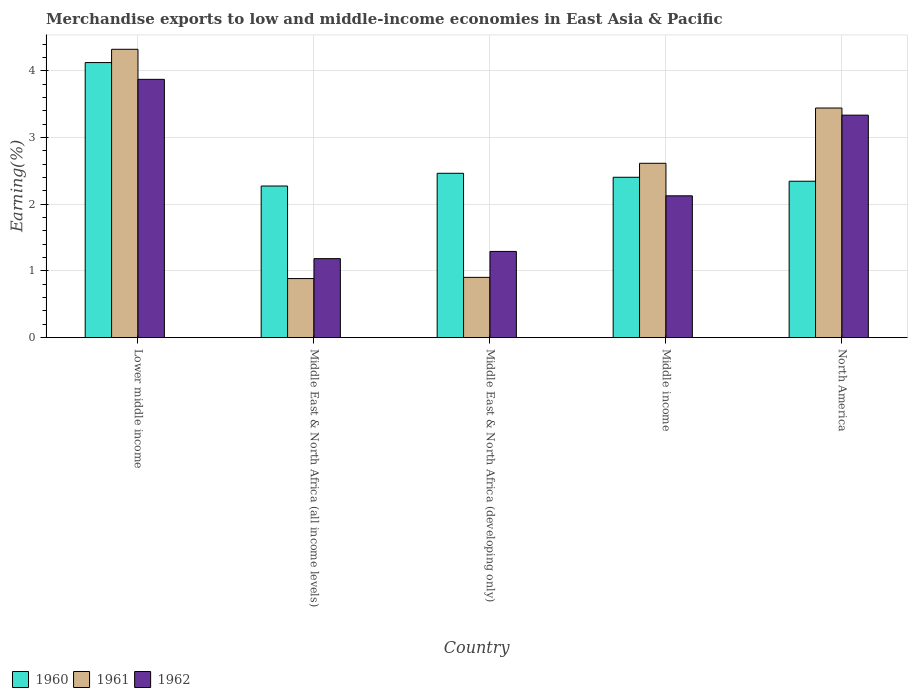How many bars are there on the 3rd tick from the left?
Make the answer very short. 3. How many bars are there on the 2nd tick from the right?
Offer a very short reply. 3. What is the label of the 3rd group of bars from the left?
Keep it short and to the point. Middle East & North Africa (developing only). In how many cases, is the number of bars for a given country not equal to the number of legend labels?
Ensure brevity in your answer.  0. What is the percentage of amount earned from merchandise exports in 1961 in North America?
Give a very brief answer. 3.44. Across all countries, what is the maximum percentage of amount earned from merchandise exports in 1962?
Ensure brevity in your answer.  3.87. Across all countries, what is the minimum percentage of amount earned from merchandise exports in 1962?
Give a very brief answer. 1.19. In which country was the percentage of amount earned from merchandise exports in 1962 maximum?
Offer a terse response. Lower middle income. In which country was the percentage of amount earned from merchandise exports in 1960 minimum?
Offer a very short reply. Middle East & North Africa (all income levels). What is the total percentage of amount earned from merchandise exports in 1962 in the graph?
Your answer should be very brief. 11.81. What is the difference between the percentage of amount earned from merchandise exports in 1962 in Middle East & North Africa (all income levels) and that in Middle income?
Your response must be concise. -0.94. What is the difference between the percentage of amount earned from merchandise exports in 1960 in Middle income and the percentage of amount earned from merchandise exports in 1961 in Lower middle income?
Provide a short and direct response. -1.92. What is the average percentage of amount earned from merchandise exports in 1961 per country?
Your response must be concise. 2.43. What is the difference between the percentage of amount earned from merchandise exports of/in 1960 and percentage of amount earned from merchandise exports of/in 1962 in Middle East & North Africa (all income levels)?
Provide a succinct answer. 1.09. In how many countries, is the percentage of amount earned from merchandise exports in 1961 greater than 1 %?
Ensure brevity in your answer.  3. What is the ratio of the percentage of amount earned from merchandise exports in 1960 in Lower middle income to that in North America?
Provide a short and direct response. 1.76. What is the difference between the highest and the second highest percentage of amount earned from merchandise exports in 1960?
Provide a short and direct response. 0.06. What is the difference between the highest and the lowest percentage of amount earned from merchandise exports in 1962?
Provide a succinct answer. 2.69. In how many countries, is the percentage of amount earned from merchandise exports in 1960 greater than the average percentage of amount earned from merchandise exports in 1960 taken over all countries?
Keep it short and to the point. 1. What does the 1st bar from the right in Lower middle income represents?
Offer a very short reply. 1962. Is it the case that in every country, the sum of the percentage of amount earned from merchandise exports in 1961 and percentage of amount earned from merchandise exports in 1962 is greater than the percentage of amount earned from merchandise exports in 1960?
Give a very brief answer. No. How many bars are there?
Offer a very short reply. 15. Does the graph contain any zero values?
Give a very brief answer. No. Where does the legend appear in the graph?
Offer a terse response. Bottom left. How many legend labels are there?
Your response must be concise. 3. How are the legend labels stacked?
Your answer should be very brief. Horizontal. What is the title of the graph?
Make the answer very short. Merchandise exports to low and middle-income economies in East Asia & Pacific. What is the label or title of the X-axis?
Make the answer very short. Country. What is the label or title of the Y-axis?
Make the answer very short. Earning(%). What is the Earning(%) in 1960 in Lower middle income?
Keep it short and to the point. 4.12. What is the Earning(%) of 1961 in Lower middle income?
Provide a short and direct response. 4.32. What is the Earning(%) of 1962 in Lower middle income?
Your answer should be very brief. 3.87. What is the Earning(%) in 1960 in Middle East & North Africa (all income levels)?
Provide a short and direct response. 2.27. What is the Earning(%) in 1961 in Middle East & North Africa (all income levels)?
Your answer should be compact. 0.89. What is the Earning(%) in 1962 in Middle East & North Africa (all income levels)?
Your response must be concise. 1.19. What is the Earning(%) in 1960 in Middle East & North Africa (developing only)?
Offer a terse response. 2.46. What is the Earning(%) in 1961 in Middle East & North Africa (developing only)?
Give a very brief answer. 0.9. What is the Earning(%) of 1962 in Middle East & North Africa (developing only)?
Offer a terse response. 1.29. What is the Earning(%) of 1960 in Middle income?
Offer a very short reply. 2.4. What is the Earning(%) of 1961 in Middle income?
Your response must be concise. 2.61. What is the Earning(%) of 1962 in Middle income?
Keep it short and to the point. 2.13. What is the Earning(%) in 1960 in North America?
Make the answer very short. 2.35. What is the Earning(%) of 1961 in North America?
Ensure brevity in your answer.  3.44. What is the Earning(%) of 1962 in North America?
Give a very brief answer. 3.34. Across all countries, what is the maximum Earning(%) of 1960?
Your response must be concise. 4.12. Across all countries, what is the maximum Earning(%) of 1961?
Make the answer very short. 4.32. Across all countries, what is the maximum Earning(%) of 1962?
Ensure brevity in your answer.  3.87. Across all countries, what is the minimum Earning(%) in 1960?
Your response must be concise. 2.27. Across all countries, what is the minimum Earning(%) in 1961?
Your answer should be compact. 0.89. Across all countries, what is the minimum Earning(%) of 1962?
Offer a very short reply. 1.19. What is the total Earning(%) of 1960 in the graph?
Your response must be concise. 13.61. What is the total Earning(%) in 1961 in the graph?
Provide a succinct answer. 12.17. What is the total Earning(%) of 1962 in the graph?
Keep it short and to the point. 11.81. What is the difference between the Earning(%) in 1960 in Lower middle income and that in Middle East & North Africa (all income levels)?
Your response must be concise. 1.85. What is the difference between the Earning(%) of 1961 in Lower middle income and that in Middle East & North Africa (all income levels)?
Your answer should be compact. 3.44. What is the difference between the Earning(%) of 1962 in Lower middle income and that in Middle East & North Africa (all income levels)?
Make the answer very short. 2.69. What is the difference between the Earning(%) in 1960 in Lower middle income and that in Middle East & North Africa (developing only)?
Offer a terse response. 1.66. What is the difference between the Earning(%) in 1961 in Lower middle income and that in Middle East & North Africa (developing only)?
Give a very brief answer. 3.42. What is the difference between the Earning(%) in 1962 in Lower middle income and that in Middle East & North Africa (developing only)?
Give a very brief answer. 2.58. What is the difference between the Earning(%) of 1960 in Lower middle income and that in Middle income?
Offer a very short reply. 1.72. What is the difference between the Earning(%) in 1961 in Lower middle income and that in Middle income?
Offer a terse response. 1.71. What is the difference between the Earning(%) of 1962 in Lower middle income and that in Middle income?
Your answer should be very brief. 1.75. What is the difference between the Earning(%) of 1960 in Lower middle income and that in North America?
Keep it short and to the point. 1.78. What is the difference between the Earning(%) in 1961 in Lower middle income and that in North America?
Provide a succinct answer. 0.88. What is the difference between the Earning(%) of 1962 in Lower middle income and that in North America?
Offer a very short reply. 0.54. What is the difference between the Earning(%) in 1960 in Middle East & North Africa (all income levels) and that in Middle East & North Africa (developing only)?
Offer a terse response. -0.19. What is the difference between the Earning(%) of 1961 in Middle East & North Africa (all income levels) and that in Middle East & North Africa (developing only)?
Ensure brevity in your answer.  -0.02. What is the difference between the Earning(%) of 1962 in Middle East & North Africa (all income levels) and that in Middle East & North Africa (developing only)?
Your answer should be compact. -0.11. What is the difference between the Earning(%) in 1960 in Middle East & North Africa (all income levels) and that in Middle income?
Provide a short and direct response. -0.13. What is the difference between the Earning(%) of 1961 in Middle East & North Africa (all income levels) and that in Middle income?
Ensure brevity in your answer.  -1.73. What is the difference between the Earning(%) in 1962 in Middle East & North Africa (all income levels) and that in Middle income?
Make the answer very short. -0.94. What is the difference between the Earning(%) in 1960 in Middle East & North Africa (all income levels) and that in North America?
Ensure brevity in your answer.  -0.07. What is the difference between the Earning(%) in 1961 in Middle East & North Africa (all income levels) and that in North America?
Ensure brevity in your answer.  -2.56. What is the difference between the Earning(%) in 1962 in Middle East & North Africa (all income levels) and that in North America?
Provide a short and direct response. -2.15. What is the difference between the Earning(%) in 1960 in Middle East & North Africa (developing only) and that in Middle income?
Provide a short and direct response. 0.06. What is the difference between the Earning(%) of 1961 in Middle East & North Africa (developing only) and that in Middle income?
Keep it short and to the point. -1.71. What is the difference between the Earning(%) of 1962 in Middle East & North Africa (developing only) and that in Middle income?
Provide a succinct answer. -0.83. What is the difference between the Earning(%) in 1960 in Middle East & North Africa (developing only) and that in North America?
Make the answer very short. 0.12. What is the difference between the Earning(%) of 1961 in Middle East & North Africa (developing only) and that in North America?
Your answer should be very brief. -2.54. What is the difference between the Earning(%) in 1962 in Middle East & North Africa (developing only) and that in North America?
Make the answer very short. -2.04. What is the difference between the Earning(%) of 1960 in Middle income and that in North America?
Your response must be concise. 0.06. What is the difference between the Earning(%) in 1961 in Middle income and that in North America?
Make the answer very short. -0.83. What is the difference between the Earning(%) of 1962 in Middle income and that in North America?
Give a very brief answer. -1.21. What is the difference between the Earning(%) of 1960 in Lower middle income and the Earning(%) of 1961 in Middle East & North Africa (all income levels)?
Provide a short and direct response. 3.24. What is the difference between the Earning(%) in 1960 in Lower middle income and the Earning(%) in 1962 in Middle East & North Africa (all income levels)?
Give a very brief answer. 2.94. What is the difference between the Earning(%) of 1961 in Lower middle income and the Earning(%) of 1962 in Middle East & North Africa (all income levels)?
Your answer should be very brief. 3.14. What is the difference between the Earning(%) of 1960 in Lower middle income and the Earning(%) of 1961 in Middle East & North Africa (developing only)?
Keep it short and to the point. 3.22. What is the difference between the Earning(%) of 1960 in Lower middle income and the Earning(%) of 1962 in Middle East & North Africa (developing only)?
Provide a short and direct response. 2.83. What is the difference between the Earning(%) in 1961 in Lower middle income and the Earning(%) in 1962 in Middle East & North Africa (developing only)?
Your response must be concise. 3.03. What is the difference between the Earning(%) in 1960 in Lower middle income and the Earning(%) in 1961 in Middle income?
Your answer should be compact. 1.51. What is the difference between the Earning(%) in 1960 in Lower middle income and the Earning(%) in 1962 in Middle income?
Ensure brevity in your answer.  2. What is the difference between the Earning(%) of 1961 in Lower middle income and the Earning(%) of 1962 in Middle income?
Ensure brevity in your answer.  2.2. What is the difference between the Earning(%) in 1960 in Lower middle income and the Earning(%) in 1961 in North America?
Keep it short and to the point. 0.68. What is the difference between the Earning(%) of 1960 in Lower middle income and the Earning(%) of 1962 in North America?
Keep it short and to the point. 0.79. What is the difference between the Earning(%) in 1961 in Lower middle income and the Earning(%) in 1962 in North America?
Make the answer very short. 0.99. What is the difference between the Earning(%) of 1960 in Middle East & North Africa (all income levels) and the Earning(%) of 1961 in Middle East & North Africa (developing only)?
Provide a succinct answer. 1.37. What is the difference between the Earning(%) in 1960 in Middle East & North Africa (all income levels) and the Earning(%) in 1962 in Middle East & North Africa (developing only)?
Provide a short and direct response. 0.98. What is the difference between the Earning(%) in 1961 in Middle East & North Africa (all income levels) and the Earning(%) in 1962 in Middle East & North Africa (developing only)?
Give a very brief answer. -0.41. What is the difference between the Earning(%) in 1960 in Middle East & North Africa (all income levels) and the Earning(%) in 1961 in Middle income?
Ensure brevity in your answer.  -0.34. What is the difference between the Earning(%) in 1960 in Middle East & North Africa (all income levels) and the Earning(%) in 1962 in Middle income?
Your response must be concise. 0.15. What is the difference between the Earning(%) in 1961 in Middle East & North Africa (all income levels) and the Earning(%) in 1962 in Middle income?
Give a very brief answer. -1.24. What is the difference between the Earning(%) of 1960 in Middle East & North Africa (all income levels) and the Earning(%) of 1961 in North America?
Provide a succinct answer. -1.17. What is the difference between the Earning(%) of 1960 in Middle East & North Africa (all income levels) and the Earning(%) of 1962 in North America?
Offer a very short reply. -1.06. What is the difference between the Earning(%) of 1961 in Middle East & North Africa (all income levels) and the Earning(%) of 1962 in North America?
Your answer should be very brief. -2.45. What is the difference between the Earning(%) in 1960 in Middle East & North Africa (developing only) and the Earning(%) in 1962 in Middle income?
Keep it short and to the point. 0.34. What is the difference between the Earning(%) in 1961 in Middle East & North Africa (developing only) and the Earning(%) in 1962 in Middle income?
Your answer should be compact. -1.22. What is the difference between the Earning(%) of 1960 in Middle East & North Africa (developing only) and the Earning(%) of 1961 in North America?
Provide a short and direct response. -0.98. What is the difference between the Earning(%) in 1960 in Middle East & North Africa (developing only) and the Earning(%) in 1962 in North America?
Give a very brief answer. -0.87. What is the difference between the Earning(%) of 1961 in Middle East & North Africa (developing only) and the Earning(%) of 1962 in North America?
Provide a succinct answer. -2.43. What is the difference between the Earning(%) of 1960 in Middle income and the Earning(%) of 1961 in North America?
Make the answer very short. -1.04. What is the difference between the Earning(%) of 1960 in Middle income and the Earning(%) of 1962 in North America?
Ensure brevity in your answer.  -0.93. What is the difference between the Earning(%) in 1961 in Middle income and the Earning(%) in 1962 in North America?
Your answer should be compact. -0.72. What is the average Earning(%) of 1960 per country?
Your answer should be compact. 2.72. What is the average Earning(%) of 1961 per country?
Provide a short and direct response. 2.43. What is the average Earning(%) in 1962 per country?
Make the answer very short. 2.36. What is the difference between the Earning(%) in 1960 and Earning(%) in 1961 in Lower middle income?
Give a very brief answer. -0.2. What is the difference between the Earning(%) in 1960 and Earning(%) in 1962 in Lower middle income?
Give a very brief answer. 0.25. What is the difference between the Earning(%) in 1961 and Earning(%) in 1962 in Lower middle income?
Your answer should be very brief. 0.45. What is the difference between the Earning(%) in 1960 and Earning(%) in 1961 in Middle East & North Africa (all income levels)?
Your answer should be very brief. 1.39. What is the difference between the Earning(%) in 1960 and Earning(%) in 1962 in Middle East & North Africa (all income levels)?
Keep it short and to the point. 1.09. What is the difference between the Earning(%) in 1961 and Earning(%) in 1962 in Middle East & North Africa (all income levels)?
Make the answer very short. -0.3. What is the difference between the Earning(%) in 1960 and Earning(%) in 1961 in Middle East & North Africa (developing only)?
Give a very brief answer. 1.56. What is the difference between the Earning(%) in 1960 and Earning(%) in 1962 in Middle East & North Africa (developing only)?
Your response must be concise. 1.17. What is the difference between the Earning(%) in 1961 and Earning(%) in 1962 in Middle East & North Africa (developing only)?
Give a very brief answer. -0.39. What is the difference between the Earning(%) of 1960 and Earning(%) of 1961 in Middle income?
Your answer should be compact. -0.21. What is the difference between the Earning(%) in 1960 and Earning(%) in 1962 in Middle income?
Make the answer very short. 0.28. What is the difference between the Earning(%) in 1961 and Earning(%) in 1962 in Middle income?
Your answer should be compact. 0.49. What is the difference between the Earning(%) of 1960 and Earning(%) of 1961 in North America?
Give a very brief answer. -1.1. What is the difference between the Earning(%) in 1960 and Earning(%) in 1962 in North America?
Offer a very short reply. -0.99. What is the difference between the Earning(%) in 1961 and Earning(%) in 1962 in North America?
Provide a short and direct response. 0.11. What is the ratio of the Earning(%) in 1960 in Lower middle income to that in Middle East & North Africa (all income levels)?
Offer a terse response. 1.81. What is the ratio of the Earning(%) of 1961 in Lower middle income to that in Middle East & North Africa (all income levels)?
Offer a very short reply. 4.88. What is the ratio of the Earning(%) in 1962 in Lower middle income to that in Middle East & North Africa (all income levels)?
Your response must be concise. 3.27. What is the ratio of the Earning(%) of 1960 in Lower middle income to that in Middle East & North Africa (developing only)?
Provide a short and direct response. 1.67. What is the ratio of the Earning(%) of 1961 in Lower middle income to that in Middle East & North Africa (developing only)?
Offer a terse response. 4.78. What is the ratio of the Earning(%) of 1962 in Lower middle income to that in Middle East & North Africa (developing only)?
Offer a terse response. 3. What is the ratio of the Earning(%) in 1960 in Lower middle income to that in Middle income?
Make the answer very short. 1.72. What is the ratio of the Earning(%) of 1961 in Lower middle income to that in Middle income?
Your answer should be compact. 1.65. What is the ratio of the Earning(%) of 1962 in Lower middle income to that in Middle income?
Offer a very short reply. 1.82. What is the ratio of the Earning(%) in 1960 in Lower middle income to that in North America?
Keep it short and to the point. 1.76. What is the ratio of the Earning(%) of 1961 in Lower middle income to that in North America?
Offer a very short reply. 1.26. What is the ratio of the Earning(%) in 1962 in Lower middle income to that in North America?
Provide a short and direct response. 1.16. What is the ratio of the Earning(%) of 1960 in Middle East & North Africa (all income levels) to that in Middle East & North Africa (developing only)?
Offer a very short reply. 0.92. What is the ratio of the Earning(%) in 1961 in Middle East & North Africa (all income levels) to that in Middle East & North Africa (developing only)?
Ensure brevity in your answer.  0.98. What is the ratio of the Earning(%) in 1962 in Middle East & North Africa (all income levels) to that in Middle East & North Africa (developing only)?
Offer a very short reply. 0.92. What is the ratio of the Earning(%) in 1960 in Middle East & North Africa (all income levels) to that in Middle income?
Give a very brief answer. 0.95. What is the ratio of the Earning(%) of 1961 in Middle East & North Africa (all income levels) to that in Middle income?
Offer a very short reply. 0.34. What is the ratio of the Earning(%) of 1962 in Middle East & North Africa (all income levels) to that in Middle income?
Your response must be concise. 0.56. What is the ratio of the Earning(%) in 1960 in Middle East & North Africa (all income levels) to that in North America?
Offer a very short reply. 0.97. What is the ratio of the Earning(%) in 1961 in Middle East & North Africa (all income levels) to that in North America?
Your answer should be compact. 0.26. What is the ratio of the Earning(%) of 1962 in Middle East & North Africa (all income levels) to that in North America?
Give a very brief answer. 0.36. What is the ratio of the Earning(%) in 1960 in Middle East & North Africa (developing only) to that in Middle income?
Offer a terse response. 1.02. What is the ratio of the Earning(%) of 1961 in Middle East & North Africa (developing only) to that in Middle income?
Provide a succinct answer. 0.35. What is the ratio of the Earning(%) in 1962 in Middle East & North Africa (developing only) to that in Middle income?
Provide a succinct answer. 0.61. What is the ratio of the Earning(%) in 1960 in Middle East & North Africa (developing only) to that in North America?
Your answer should be very brief. 1.05. What is the ratio of the Earning(%) of 1961 in Middle East & North Africa (developing only) to that in North America?
Give a very brief answer. 0.26. What is the ratio of the Earning(%) in 1962 in Middle East & North Africa (developing only) to that in North America?
Provide a short and direct response. 0.39. What is the ratio of the Earning(%) of 1960 in Middle income to that in North America?
Make the answer very short. 1.03. What is the ratio of the Earning(%) of 1961 in Middle income to that in North America?
Your answer should be very brief. 0.76. What is the ratio of the Earning(%) of 1962 in Middle income to that in North America?
Provide a short and direct response. 0.64. What is the difference between the highest and the second highest Earning(%) in 1960?
Give a very brief answer. 1.66. What is the difference between the highest and the second highest Earning(%) of 1961?
Offer a terse response. 0.88. What is the difference between the highest and the second highest Earning(%) in 1962?
Your answer should be very brief. 0.54. What is the difference between the highest and the lowest Earning(%) in 1960?
Make the answer very short. 1.85. What is the difference between the highest and the lowest Earning(%) in 1961?
Provide a succinct answer. 3.44. What is the difference between the highest and the lowest Earning(%) of 1962?
Your answer should be compact. 2.69. 